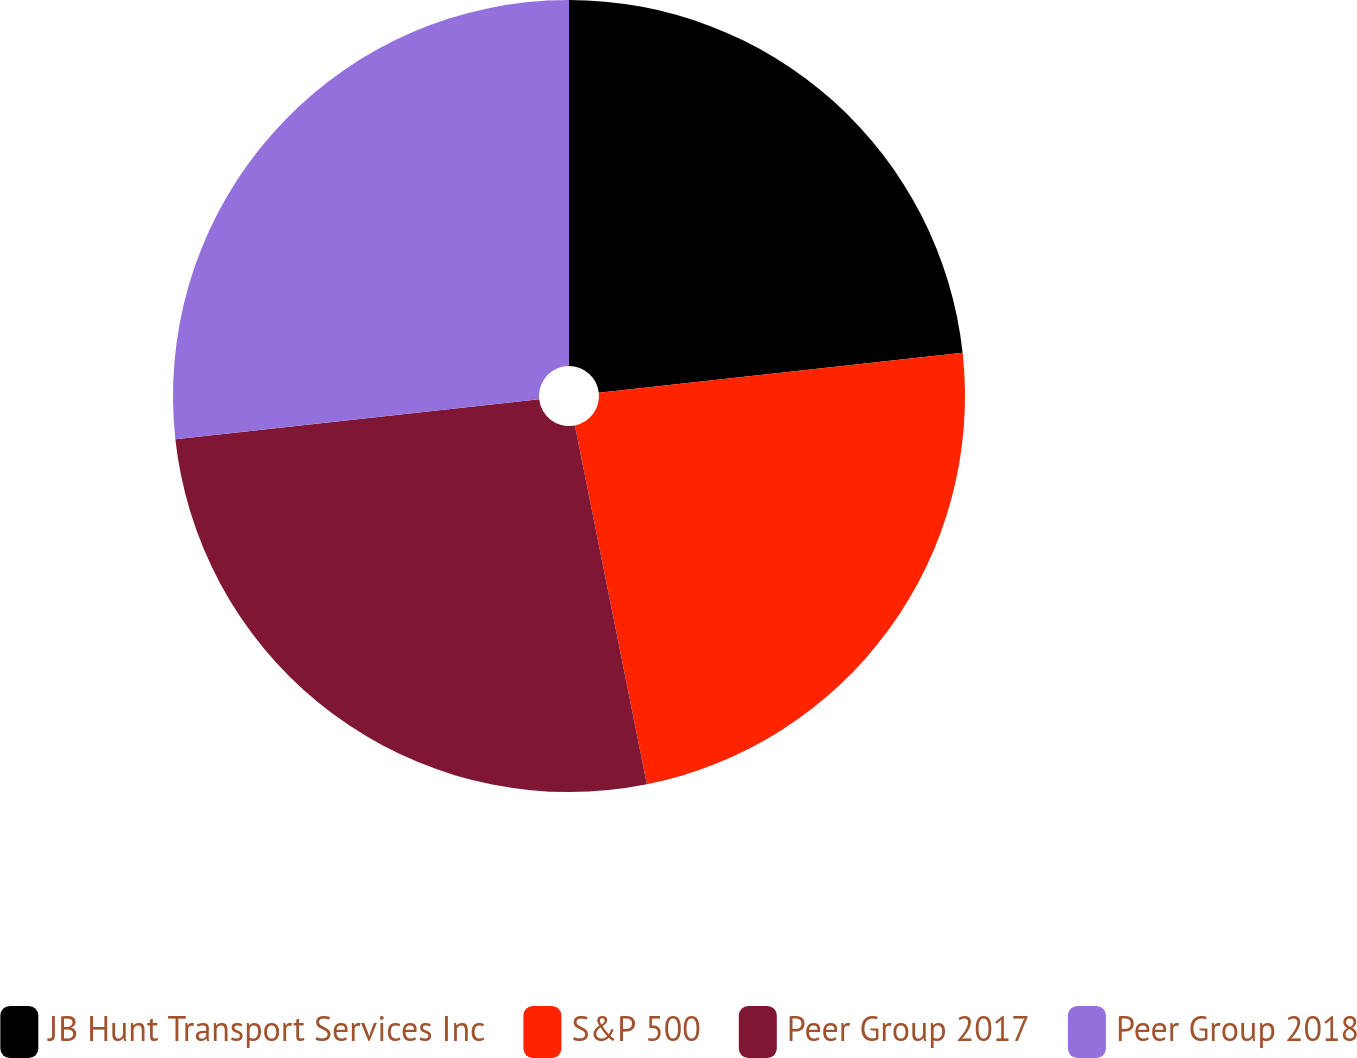Convert chart to OTSL. <chart><loc_0><loc_0><loc_500><loc_500><pie_chart><fcel>JB Hunt Transport Services Inc<fcel>S&P 500<fcel>Peer Group 2017<fcel>Peer Group 2018<nl><fcel>23.26%<fcel>23.59%<fcel>26.41%<fcel>26.74%<nl></chart> 